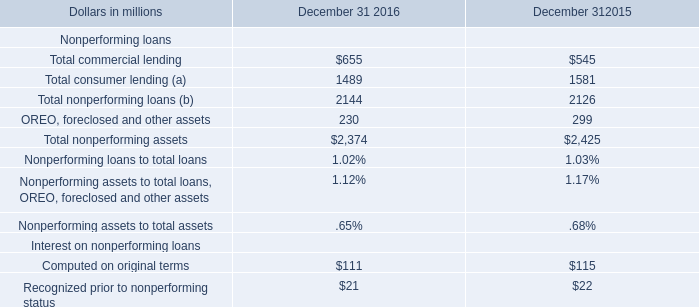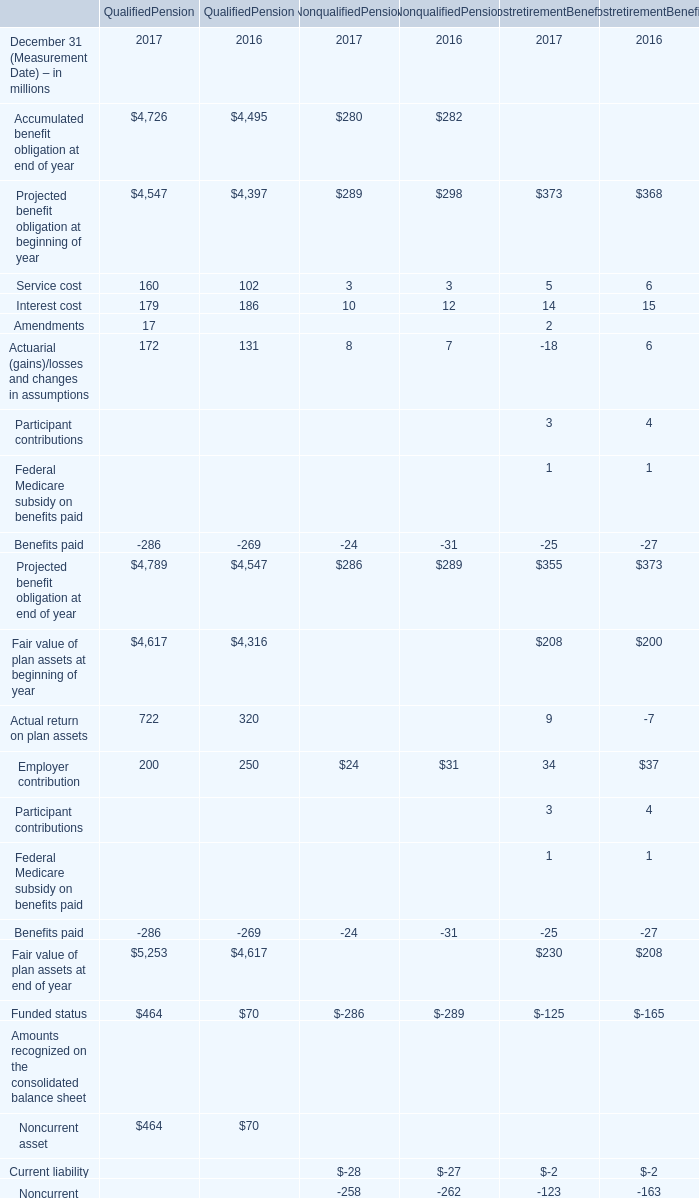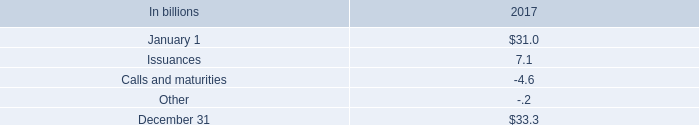Which year is Projected benefit obligation at end of year for non qualified pension the least? 
Answer: 2017. 